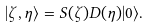Convert formula to latex. <formula><loc_0><loc_0><loc_500><loc_500>| \zeta , \eta \rangle = S ( \zeta ) D ( \eta ) | 0 \rangle .</formula> 